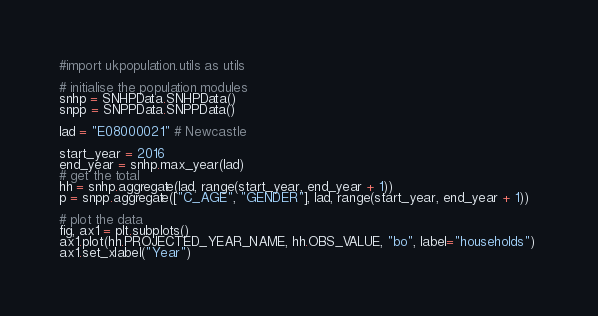<code> <loc_0><loc_0><loc_500><loc_500><_Python_>#import ukpopulation.utils as utils

# initialise the population modules
snhp = SNHPData.SNHPData()
snpp = SNPPData.SNPPData()

lad = "E08000021" # Newcastle

start_year = 2016
end_year = snhp.max_year(lad)
# get the total 
hh = snhp.aggregate(lad, range(start_year, end_year + 1))
p = snpp.aggregate(["C_AGE", "GENDER"], lad, range(start_year, end_year + 1)) 

# plot the data
fig, ax1 = plt.subplots()
ax1.plot(hh.PROJECTED_YEAR_NAME, hh.OBS_VALUE, "bo", label="households") 
ax1.set_xlabel("Year")</code> 